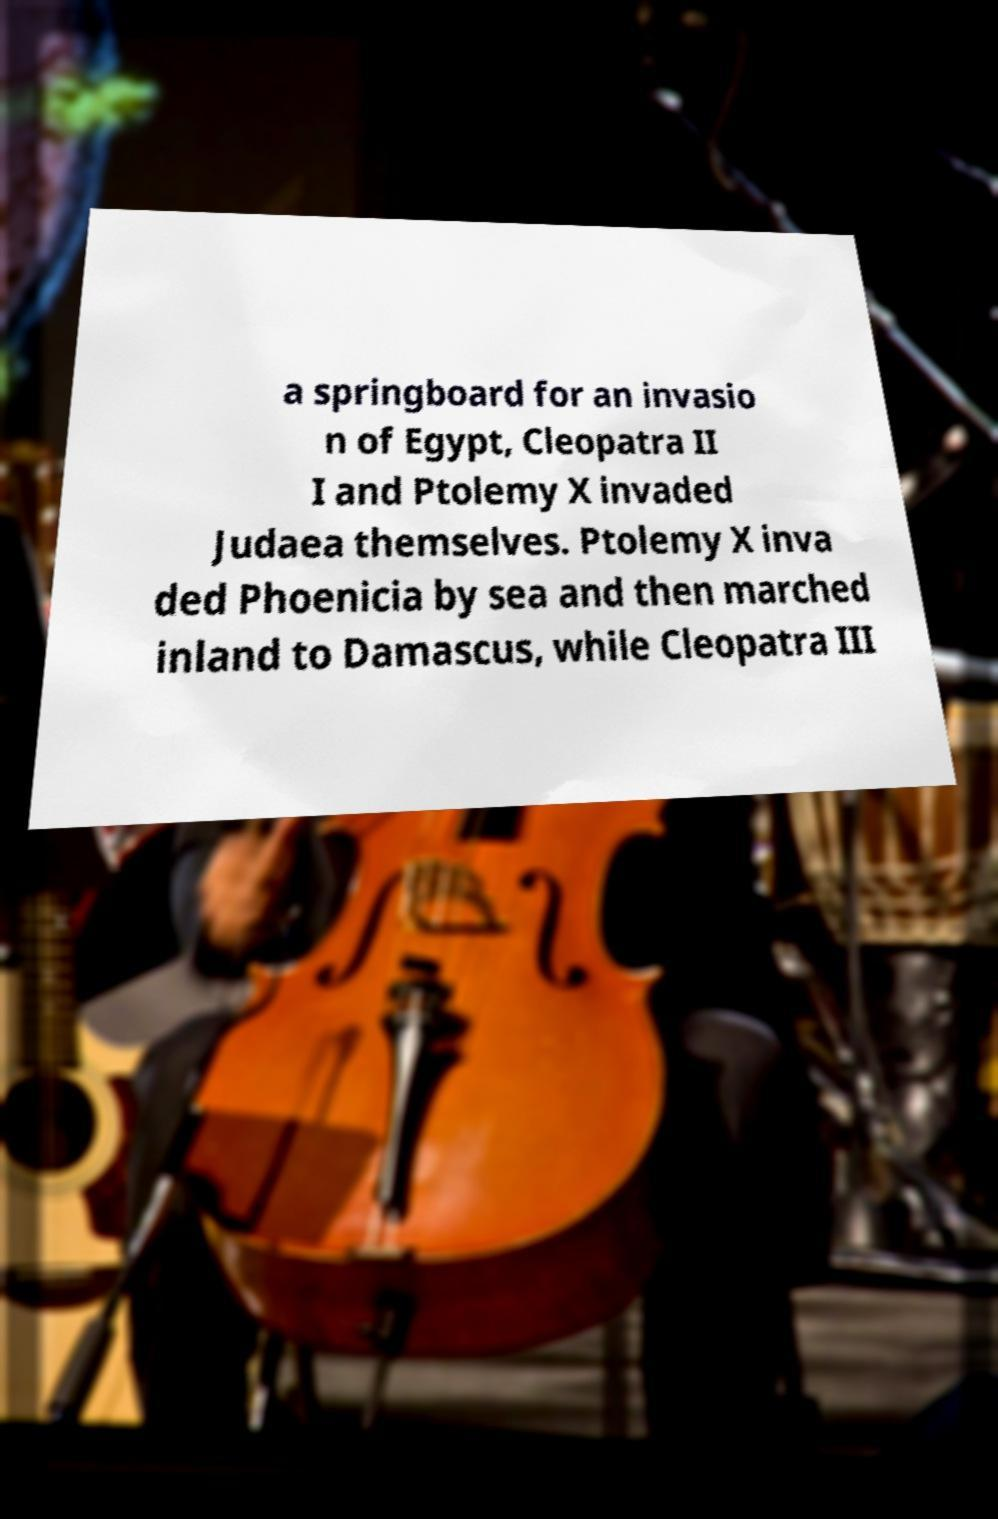I need the written content from this picture converted into text. Can you do that? a springboard for an invasio n of Egypt, Cleopatra II I and Ptolemy X invaded Judaea themselves. Ptolemy X inva ded Phoenicia by sea and then marched inland to Damascus, while Cleopatra III 